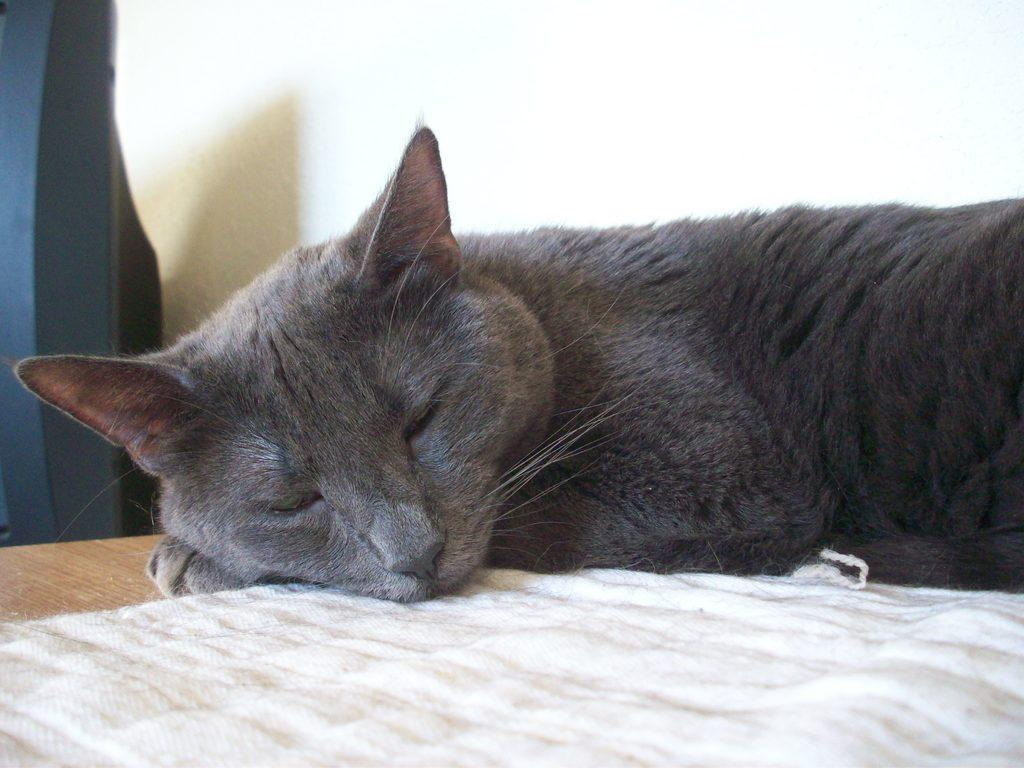What animal can be seen in the image? There is a cat in the image. What is the cat doing in the image? The cat is sleeping. On what type of surface is the cat resting? The cat is on a wooden surface. What is the color of the cloth in the image? There is a white cloth in the image. What can be seen in the background of the image? There is a wall in the background of the image. What is the color of the object on the left side of the image? There is a black color object on the left side of the image. Can you see a goat in the image? No, there is no goat present in the image. What shape is the roof in the image? There is no roof present in the image. 